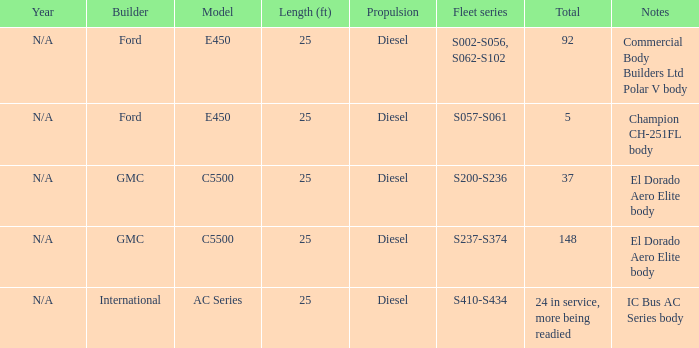How many builders are there on a global scale? 24 in service, more being readied. 